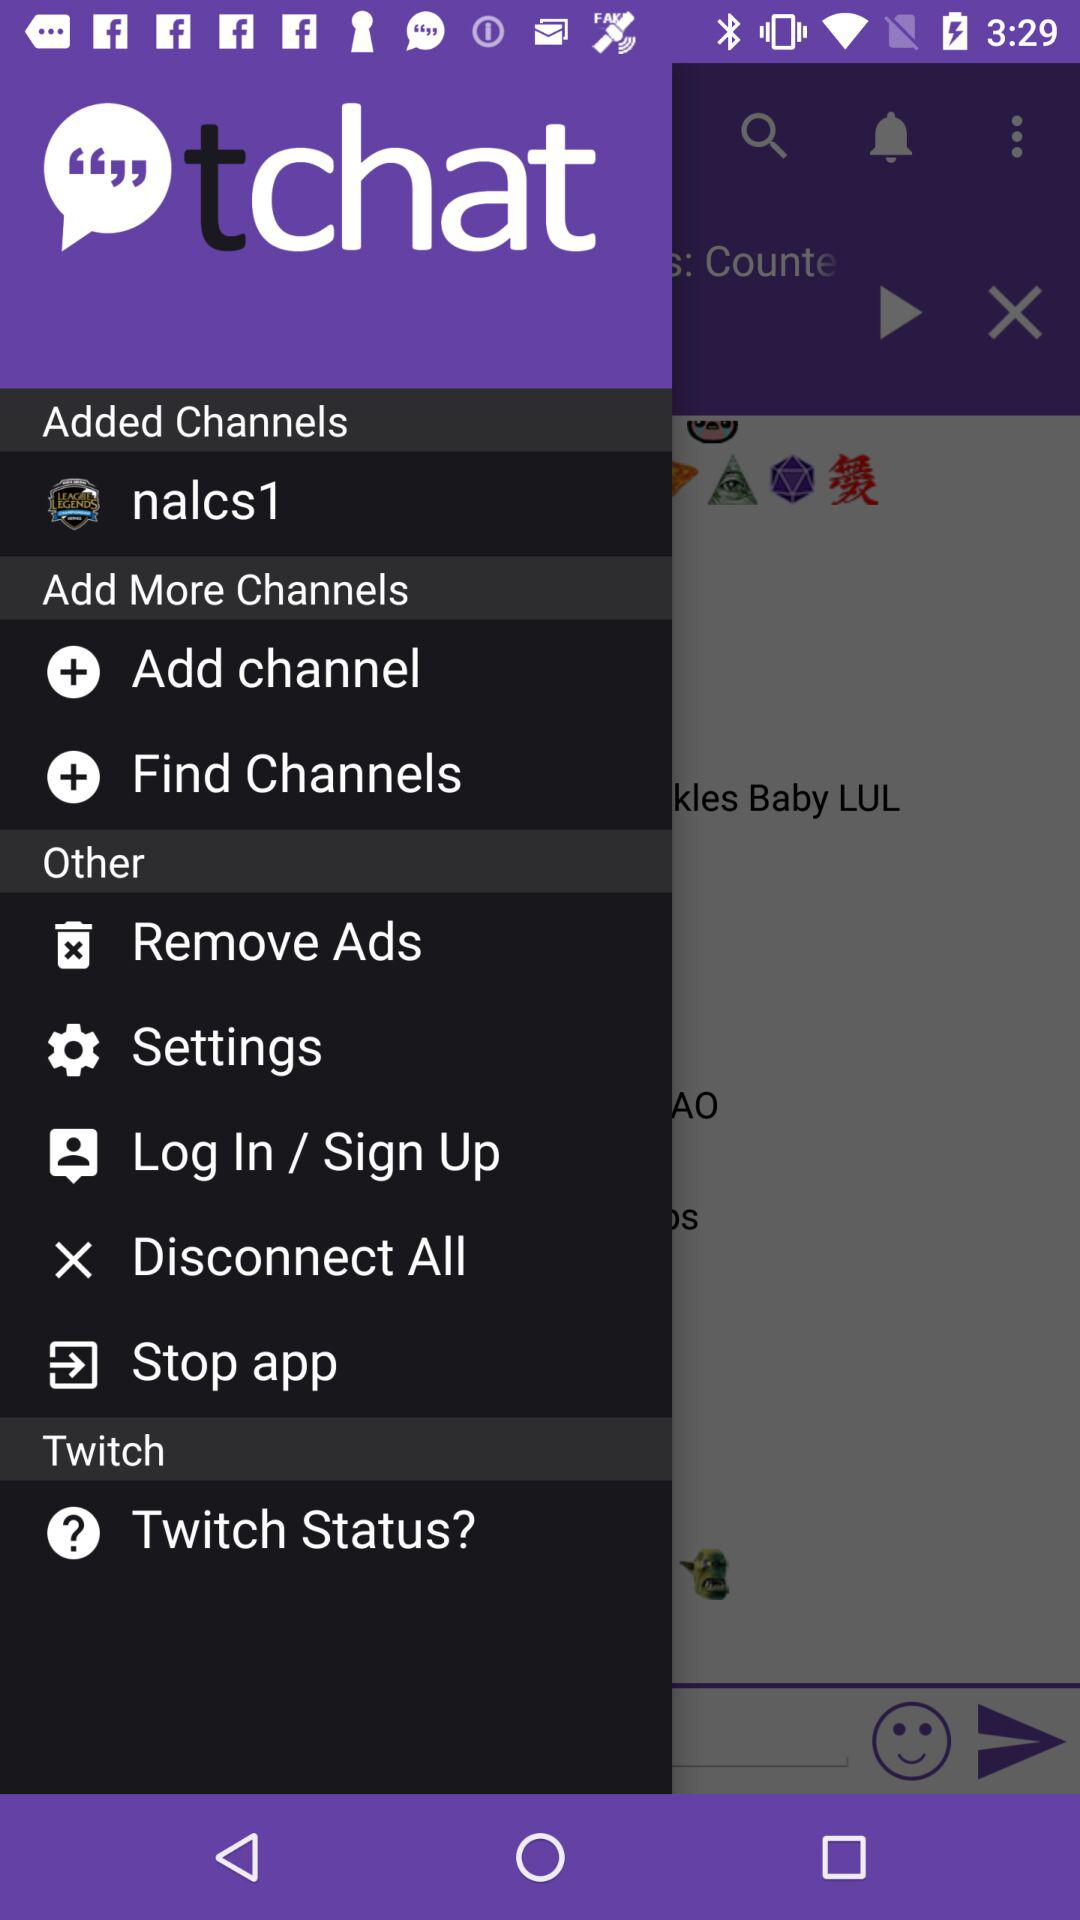What is the name of the added channel? The name of the added channel is "nalcs1". 